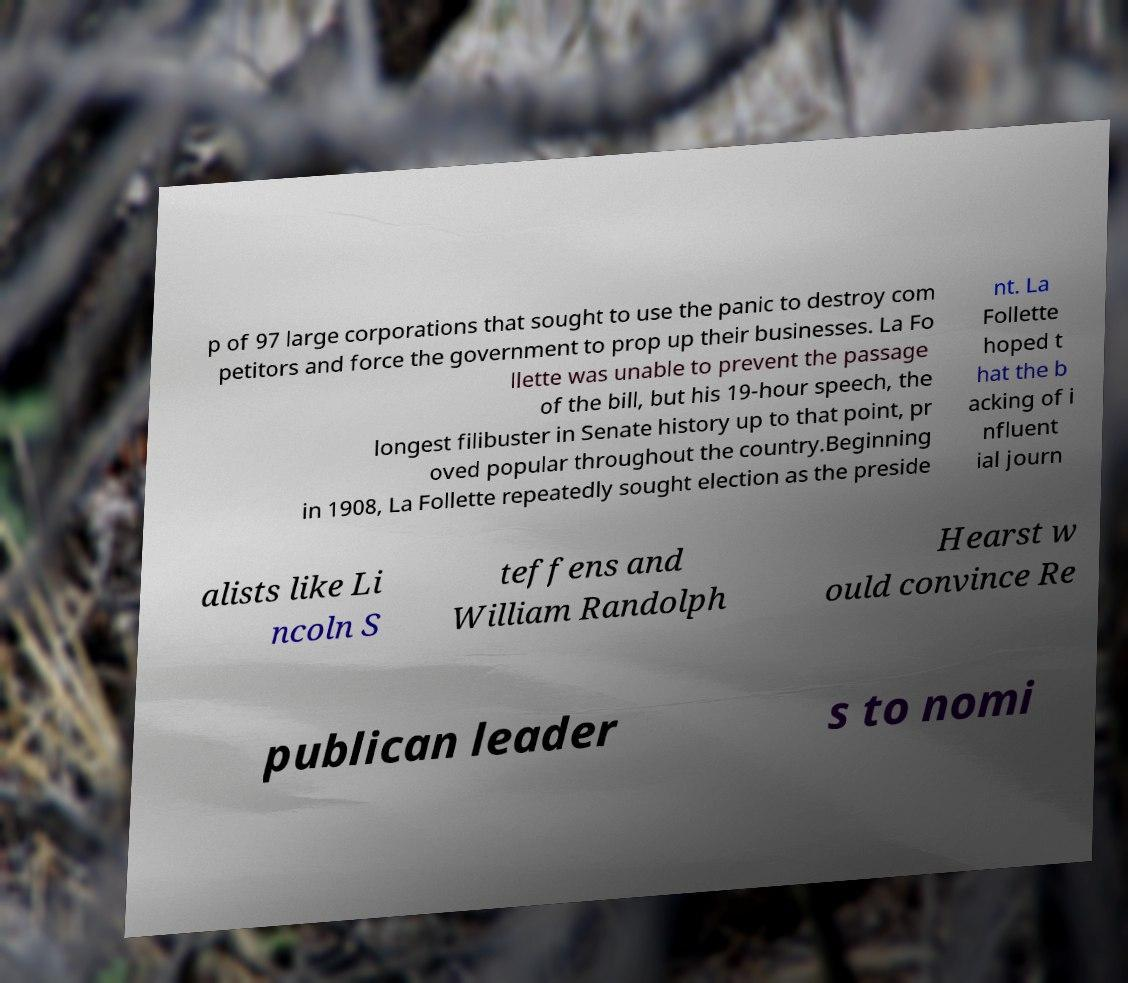For documentation purposes, I need the text within this image transcribed. Could you provide that? p of 97 large corporations that sought to use the panic to destroy com petitors and force the government to prop up their businesses. La Fo llette was unable to prevent the passage of the bill, but his 19-hour speech, the longest filibuster in Senate history up to that point, pr oved popular throughout the country.Beginning in 1908, La Follette repeatedly sought election as the preside nt. La Follette hoped t hat the b acking of i nfluent ial journ alists like Li ncoln S teffens and William Randolph Hearst w ould convince Re publican leader s to nomi 